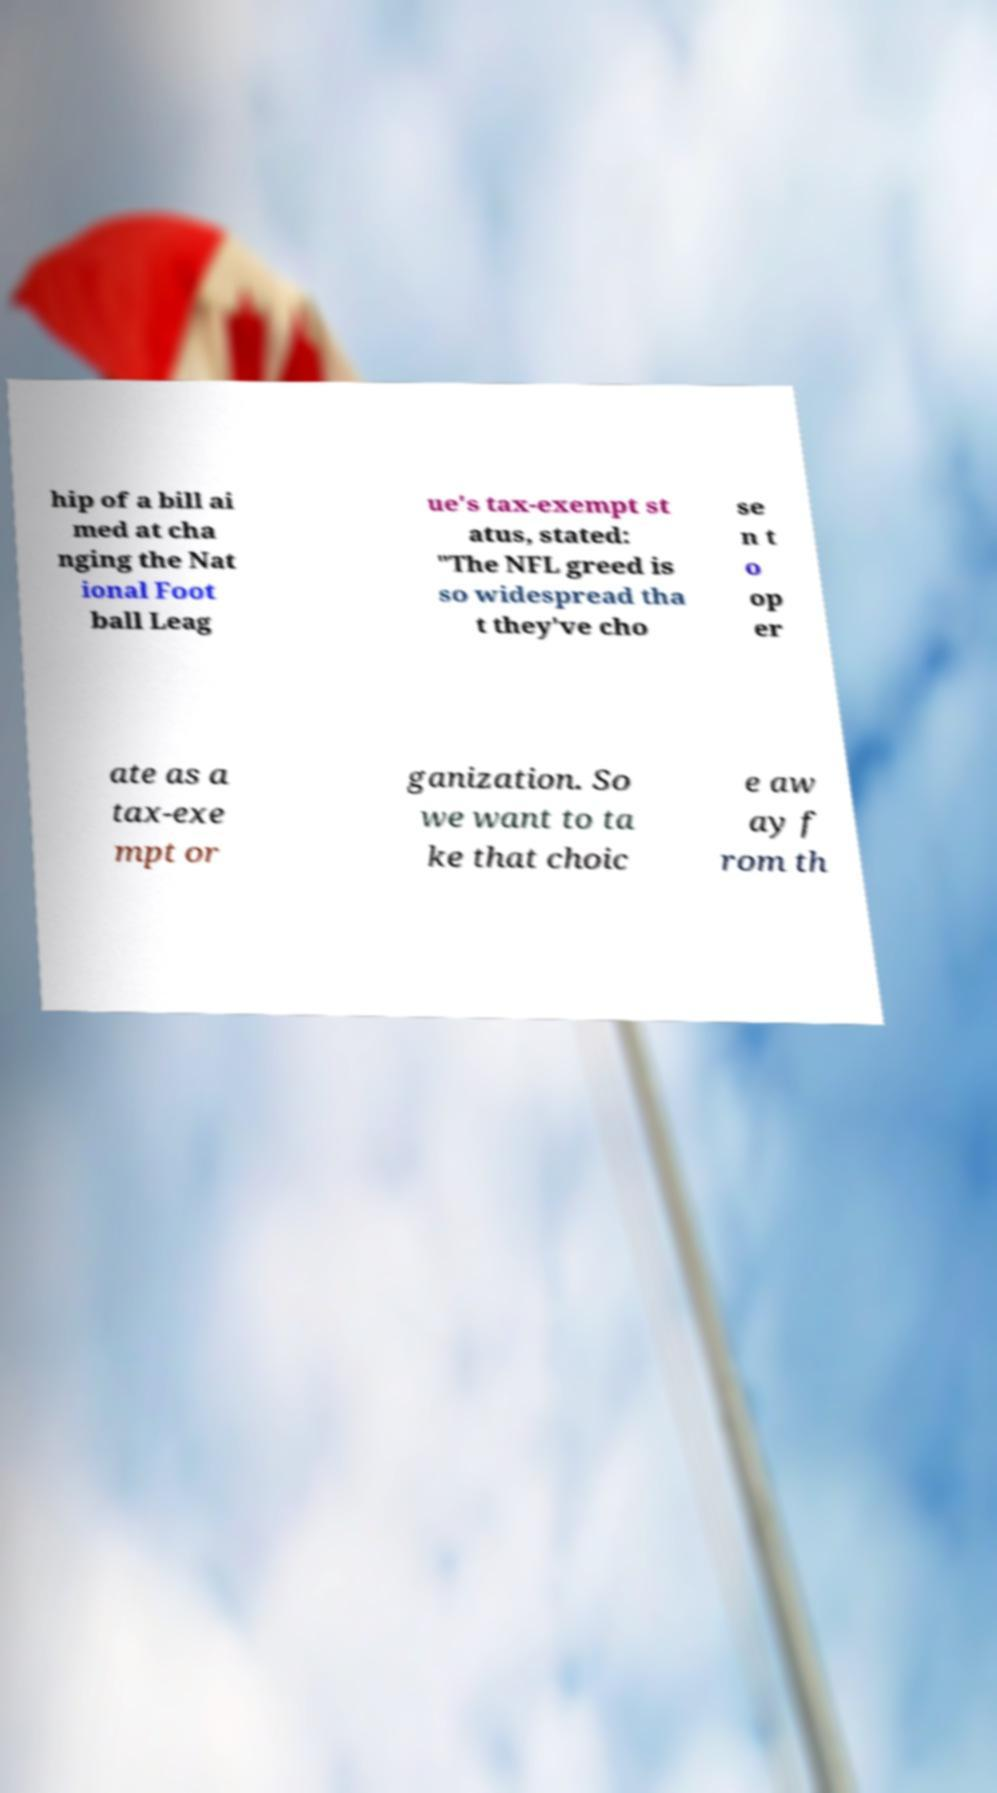Could you assist in decoding the text presented in this image and type it out clearly? hip of a bill ai med at cha nging the Nat ional Foot ball Leag ue's tax-exempt st atus, stated: "The NFL greed is so widespread tha t they've cho se n t o op er ate as a tax-exe mpt or ganization. So we want to ta ke that choic e aw ay f rom th 